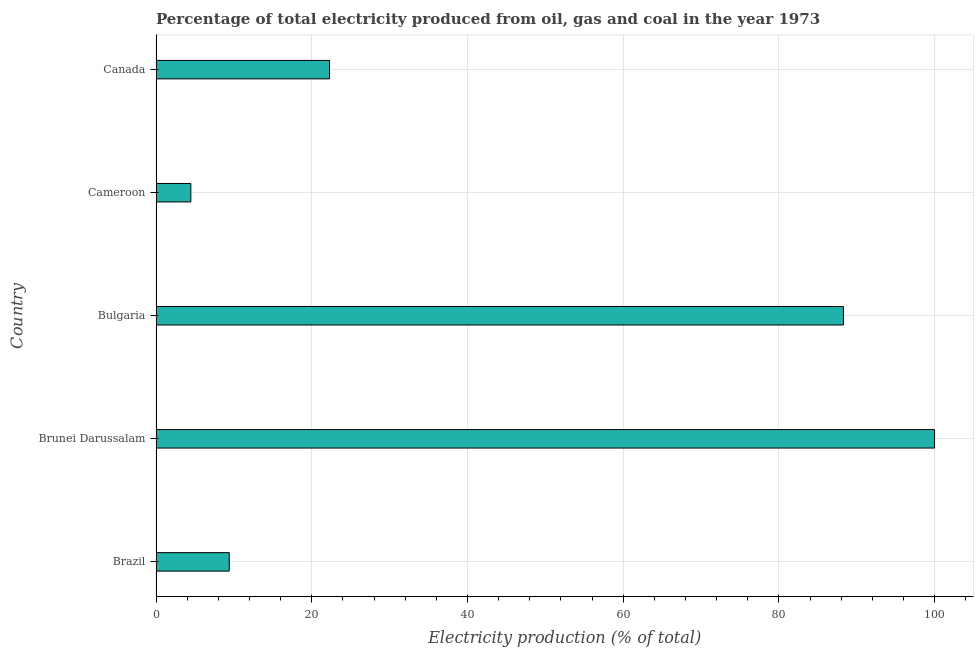Does the graph contain grids?
Provide a succinct answer. Yes. What is the title of the graph?
Ensure brevity in your answer.  Percentage of total electricity produced from oil, gas and coal in the year 1973. What is the label or title of the X-axis?
Your answer should be very brief. Electricity production (% of total). What is the label or title of the Y-axis?
Provide a short and direct response. Country. What is the electricity production in Cameroon?
Provide a succinct answer. 4.47. Across all countries, what is the maximum electricity production?
Your response must be concise. 100. Across all countries, what is the minimum electricity production?
Offer a terse response. 4.47. In which country was the electricity production maximum?
Your answer should be very brief. Brunei Darussalam. In which country was the electricity production minimum?
Ensure brevity in your answer.  Cameroon. What is the sum of the electricity production?
Keep it short and to the point. 224.45. What is the difference between the electricity production in Brunei Darussalam and Bulgaria?
Provide a succinct answer. 11.71. What is the average electricity production per country?
Provide a short and direct response. 44.89. What is the median electricity production?
Offer a terse response. 22.28. In how many countries, is the electricity production greater than 80 %?
Offer a very short reply. 2. What is the ratio of the electricity production in Brunei Darussalam to that in Bulgaria?
Ensure brevity in your answer.  1.13. Is the difference between the electricity production in Bulgaria and Cameroon greater than the difference between any two countries?
Give a very brief answer. No. What is the difference between the highest and the second highest electricity production?
Offer a terse response. 11.71. What is the difference between the highest and the lowest electricity production?
Your answer should be very brief. 95.53. In how many countries, is the electricity production greater than the average electricity production taken over all countries?
Provide a succinct answer. 2. How many bars are there?
Your answer should be compact. 5. Are all the bars in the graph horizontal?
Ensure brevity in your answer.  Yes. How many countries are there in the graph?
Make the answer very short. 5. What is the difference between two consecutive major ticks on the X-axis?
Make the answer very short. 20. What is the Electricity production (% of total) in Brazil?
Offer a very short reply. 9.4. What is the Electricity production (% of total) in Bulgaria?
Your answer should be very brief. 88.29. What is the Electricity production (% of total) in Cameroon?
Keep it short and to the point. 4.47. What is the Electricity production (% of total) in Canada?
Ensure brevity in your answer.  22.28. What is the difference between the Electricity production (% of total) in Brazil and Brunei Darussalam?
Give a very brief answer. -90.6. What is the difference between the Electricity production (% of total) in Brazil and Bulgaria?
Your answer should be compact. -78.89. What is the difference between the Electricity production (% of total) in Brazil and Cameroon?
Your answer should be compact. 4.93. What is the difference between the Electricity production (% of total) in Brazil and Canada?
Give a very brief answer. -12.88. What is the difference between the Electricity production (% of total) in Brunei Darussalam and Bulgaria?
Your answer should be very brief. 11.71. What is the difference between the Electricity production (% of total) in Brunei Darussalam and Cameroon?
Provide a succinct answer. 95.53. What is the difference between the Electricity production (% of total) in Brunei Darussalam and Canada?
Your answer should be compact. 77.72. What is the difference between the Electricity production (% of total) in Bulgaria and Cameroon?
Offer a very short reply. 83.82. What is the difference between the Electricity production (% of total) in Bulgaria and Canada?
Ensure brevity in your answer.  66.02. What is the difference between the Electricity production (% of total) in Cameroon and Canada?
Ensure brevity in your answer.  -17.81. What is the ratio of the Electricity production (% of total) in Brazil to that in Brunei Darussalam?
Ensure brevity in your answer.  0.09. What is the ratio of the Electricity production (% of total) in Brazil to that in Bulgaria?
Your answer should be very brief. 0.11. What is the ratio of the Electricity production (% of total) in Brazil to that in Cameroon?
Ensure brevity in your answer.  2.1. What is the ratio of the Electricity production (% of total) in Brazil to that in Canada?
Your answer should be compact. 0.42. What is the ratio of the Electricity production (% of total) in Brunei Darussalam to that in Bulgaria?
Provide a succinct answer. 1.13. What is the ratio of the Electricity production (% of total) in Brunei Darussalam to that in Cameroon?
Offer a terse response. 22.36. What is the ratio of the Electricity production (% of total) in Brunei Darussalam to that in Canada?
Provide a succinct answer. 4.49. What is the ratio of the Electricity production (% of total) in Bulgaria to that in Cameroon?
Offer a terse response. 19.74. What is the ratio of the Electricity production (% of total) in Bulgaria to that in Canada?
Ensure brevity in your answer.  3.96. What is the ratio of the Electricity production (% of total) in Cameroon to that in Canada?
Your answer should be very brief. 0.2. 